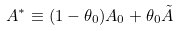<formula> <loc_0><loc_0><loc_500><loc_500>A ^ { * } \equiv ( 1 - \theta _ { 0 } ) A _ { 0 } + \theta _ { 0 } \tilde { A }</formula> 